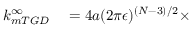<formula> <loc_0><loc_0><loc_500><loc_500>\begin{array} { r l } { k _ { m T G D } ^ { \infty } } & = 4 a ( 2 \pi \epsilon ) ^ { ( N - 3 ) / 2 } \times } \end{array}</formula> 